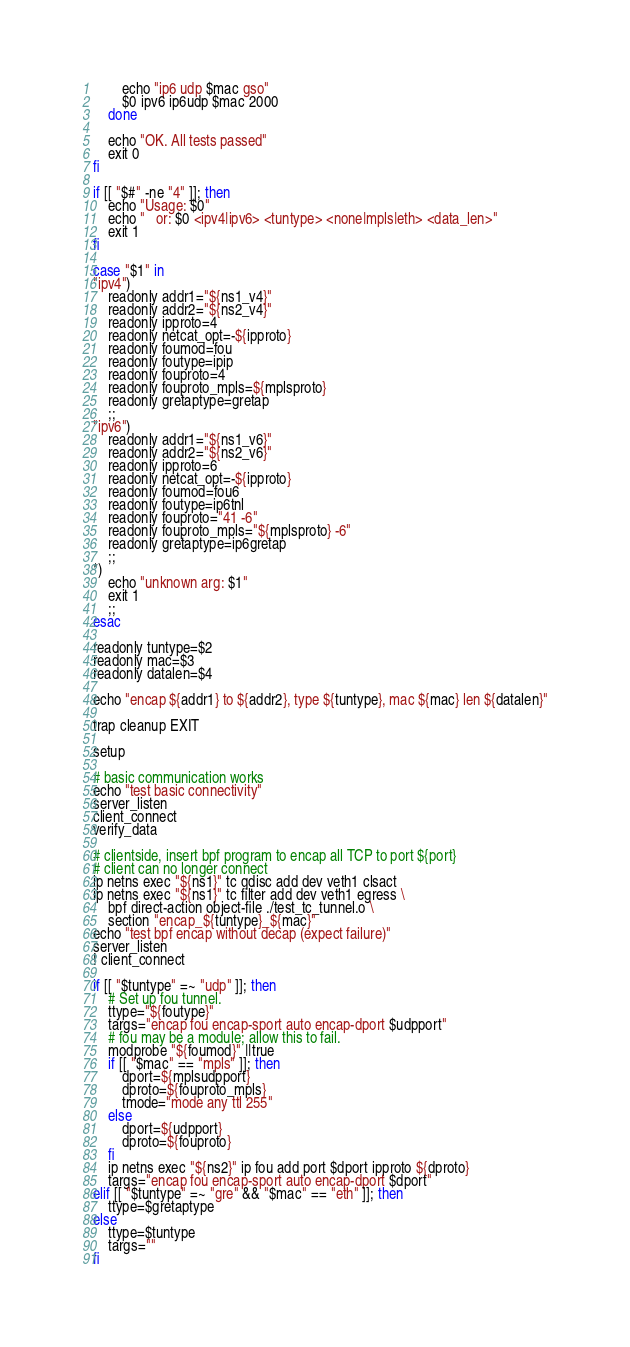<code> <loc_0><loc_0><loc_500><loc_500><_Bash_>		echo "ip6 udp $mac gso"
		$0 ipv6 ip6udp $mac 2000
	done

	echo "OK. All tests passed"
	exit 0
fi

if [[ "$#" -ne "4" ]]; then
	echo "Usage: $0"
	echo "   or: $0 <ipv4|ipv6> <tuntype> <none|mpls|eth> <data_len>"
	exit 1
fi

case "$1" in
"ipv4")
	readonly addr1="${ns1_v4}"
	readonly addr2="${ns2_v4}"
	readonly ipproto=4
	readonly netcat_opt=-${ipproto}
	readonly foumod=fou
	readonly foutype=ipip
	readonly fouproto=4
	readonly fouproto_mpls=${mplsproto}
	readonly gretaptype=gretap
	;;
"ipv6")
	readonly addr1="${ns1_v6}"
	readonly addr2="${ns2_v6}"
	readonly ipproto=6
	readonly netcat_opt=-${ipproto}
	readonly foumod=fou6
	readonly foutype=ip6tnl
	readonly fouproto="41 -6"
	readonly fouproto_mpls="${mplsproto} -6"
	readonly gretaptype=ip6gretap
	;;
*)
	echo "unknown arg: $1"
	exit 1
	;;
esac

readonly tuntype=$2
readonly mac=$3
readonly datalen=$4

echo "encap ${addr1} to ${addr2}, type ${tuntype}, mac ${mac} len ${datalen}"

trap cleanup EXIT

setup

# basic communication works
echo "test basic connectivity"
server_listen
client_connect
verify_data

# clientside, insert bpf program to encap all TCP to port ${port}
# client can no longer connect
ip netns exec "${ns1}" tc qdisc add dev veth1 clsact
ip netns exec "${ns1}" tc filter add dev veth1 egress \
	bpf direct-action object-file ./test_tc_tunnel.o \
	section "encap_${tuntype}_${mac}"
echo "test bpf encap without decap (expect failure)"
server_listen
! client_connect

if [[ "$tuntype" =~ "udp" ]]; then
	# Set up fou tunnel.
	ttype="${foutype}"
	targs="encap fou encap-sport auto encap-dport $udpport"
	# fou may be a module; allow this to fail.
	modprobe "${foumod}" ||true
	if [[ "$mac" == "mpls" ]]; then
		dport=${mplsudpport}
		dproto=${fouproto_mpls}
		tmode="mode any ttl 255"
	else
		dport=${udpport}
		dproto=${fouproto}
	fi
	ip netns exec "${ns2}" ip fou add port $dport ipproto ${dproto}
	targs="encap fou encap-sport auto encap-dport $dport"
elif [[ "$tuntype" =~ "gre" && "$mac" == "eth" ]]; then
	ttype=$gretaptype
else
	ttype=$tuntype
	targs=""
fi
</code> 